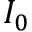Convert formula to latex. <formula><loc_0><loc_0><loc_500><loc_500>I _ { 0 }</formula> 